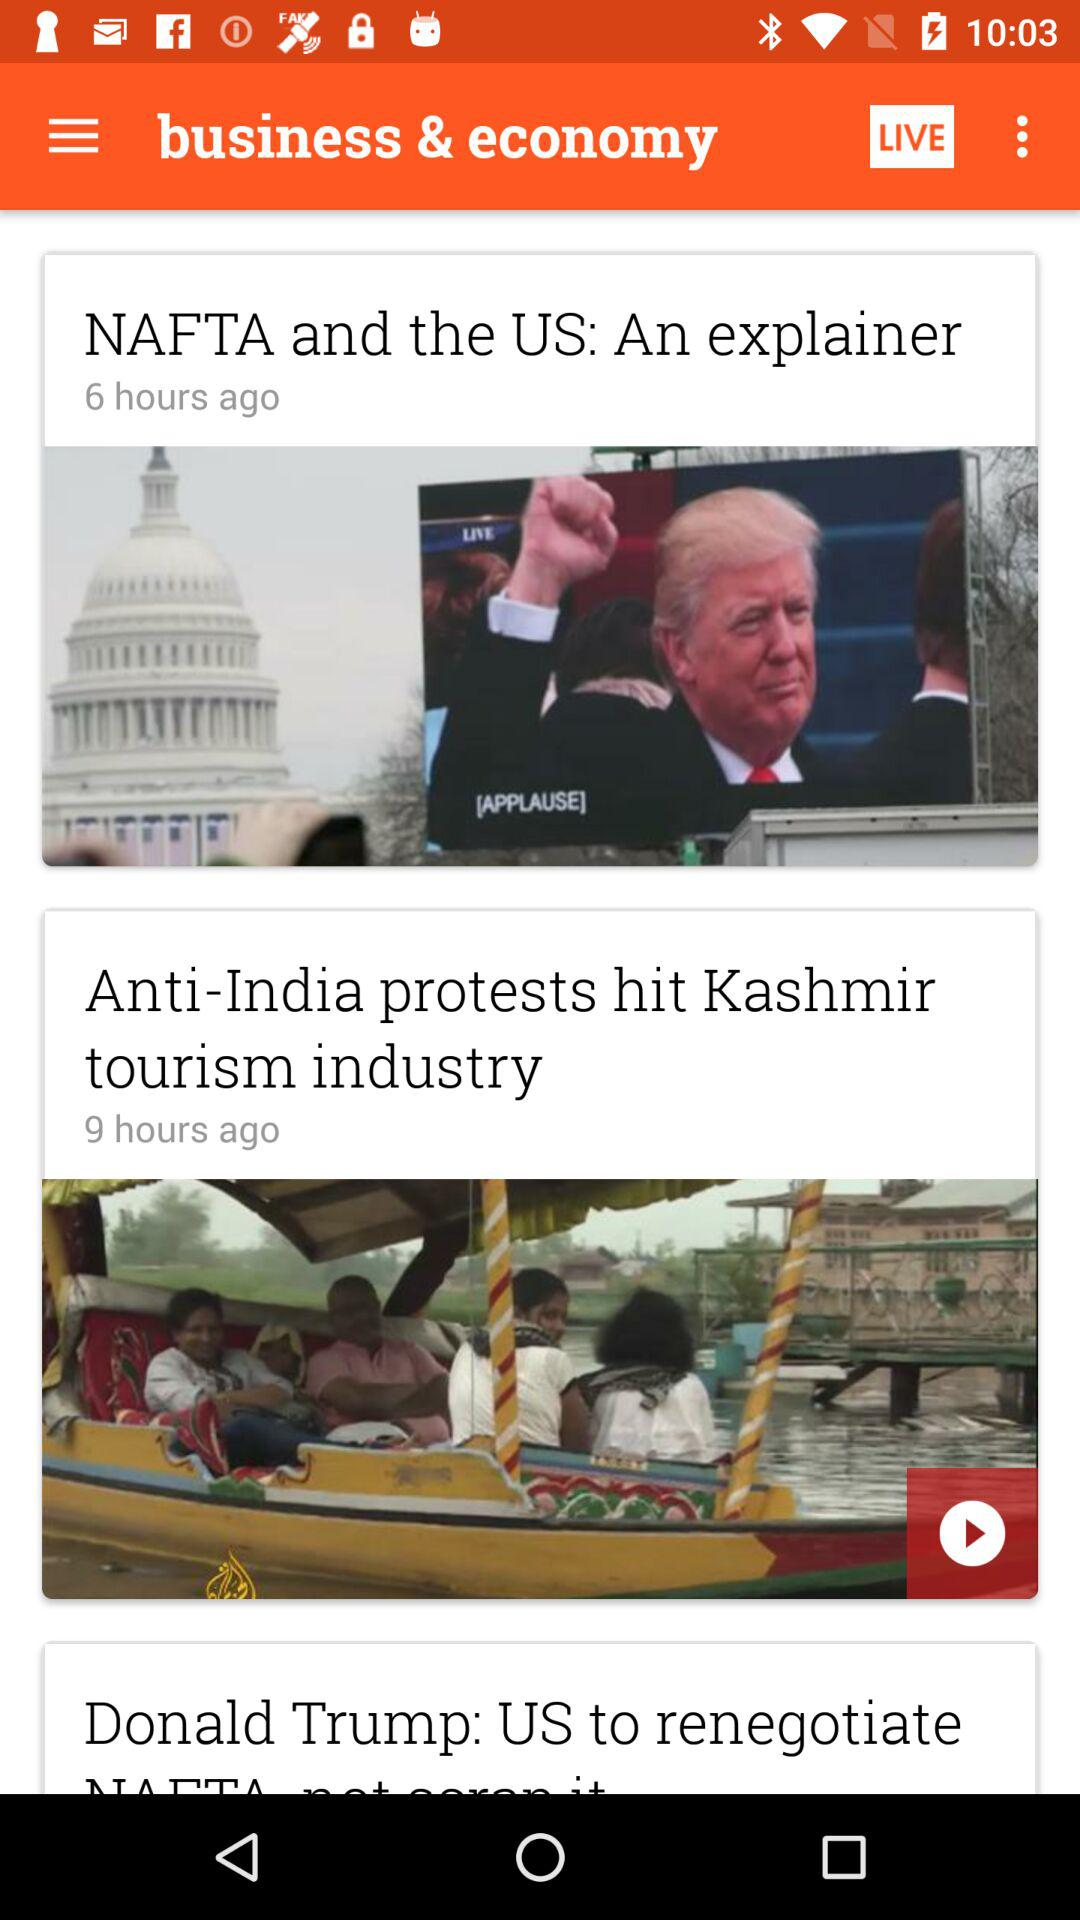Which news was published 6 hours ago? The news that was published 6 hours ago is "NAFTA and the US: An explainer". 